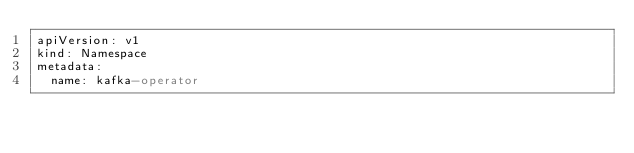Convert code to text. <code><loc_0><loc_0><loc_500><loc_500><_YAML_>apiVersion: v1
kind: Namespace
metadata:
  name: kafka-operator
</code> 